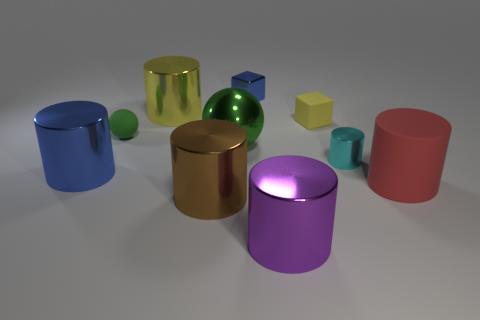Is there a purple object of the same shape as the tiny green matte object?
Ensure brevity in your answer.  No. What is the color of the matte cube that is the same size as the cyan metallic cylinder?
Provide a succinct answer. Yellow. There is a yellow object right of the purple metal thing; what size is it?
Your answer should be very brief. Small. Is there a shiny cylinder that is right of the blue object that is to the right of the large blue object?
Offer a terse response. Yes. Are the big red thing that is to the right of the big green metallic sphere and the large green ball made of the same material?
Make the answer very short. No. What number of big objects are in front of the tiny yellow thing and behind the cyan cylinder?
Ensure brevity in your answer.  1. How many green spheres have the same material as the tiny cyan cylinder?
Your answer should be very brief. 1. The block that is made of the same material as the large green ball is what color?
Keep it short and to the point. Blue. Is the number of big red rubber objects less than the number of tiny green cubes?
Give a very brief answer. No. What is the material of the large brown thing right of the yellow shiny thing on the right side of the small rubber object left of the brown object?
Offer a very short reply. Metal. 